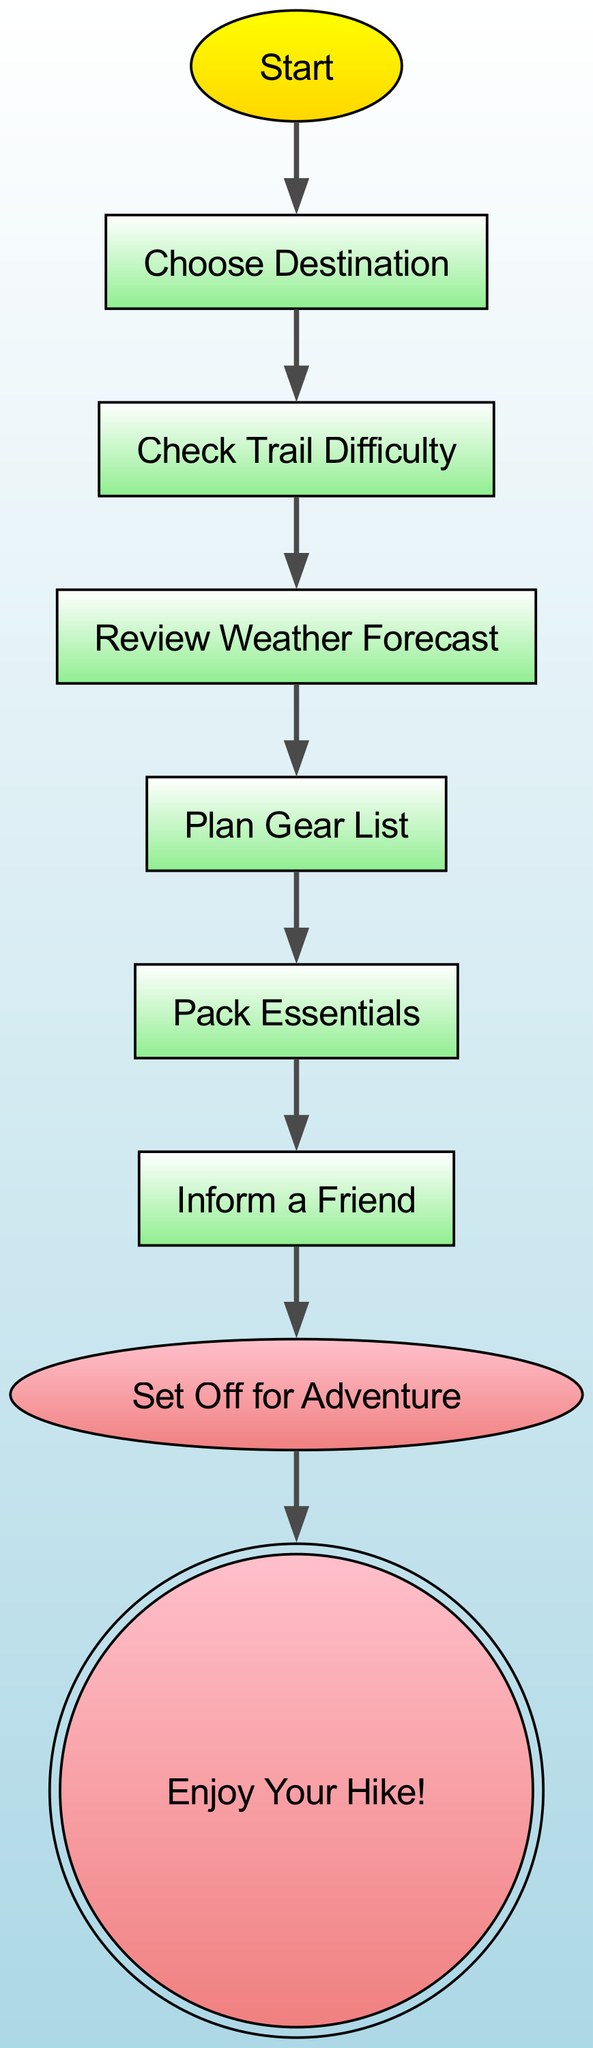What is the first step in the hiking preparation checklist? The flowchart indicates that the first node is "Start," which then leads to "Choose Destination." Therefore, the first step in the checklist is "Choose Destination."
Answer: Choose Destination How many steps are there before setting off for the adventure? Counting the nodes from "Choose Destination" to "Set Off for Adventure," there are six steps in total: "Choose Destination," "Check Trail Difficulty," "Review Weather Forecast," "Plan Gear List," "Pack Essentials," and "Inform a Friend."
Answer: 6 What is the last step in the hiking preparation checklist? The last node in the flowchart is "Enjoy Your Hike!" which follows "Set Off for Adventure." Therefore, the last step is "Enjoy Your Hike!"
Answer: Enjoy Your Hike! What step follows "Review Weather Forecast"? According to the flowchart, after the node "Review Weather Forecast," the next step is "Plan Gear List." This can be directly seen in the flow from the first to the subsequent steps.
Answer: Plan Gear List What color represents the "Start" node? In the diagram, the "Start" node is colored in gold to yellow gradient, making it distinct from other nodes.
Answer: Gold to yellow gradient What is the relationship between "Inform a Friend" and "Set Off for Adventure"? The diagram shows a direct connection where "Inform a Friend" leads to "Set Off for Adventure." This indicates that you need to inform a friend before you can set off on the hike.
Answer: Inform a Friend leads to Set Off for Adventure How many nodes are there in total in the hiking preparation checklist? The checklist includes the following nodes: "Start," "Choose Destination," "Check Trail Difficulty," "Review Weather Forecast," "Plan Gear List," "Pack Essentials," "Inform a Friend," "Set Off for Adventure," and "Enjoy Your Hike!" Counting all these gives a total of nine nodes.
Answer: 9 What step requires you to review the weather? The step that involves reviewing the weather is labeled as "Review Weather Forecast," derived from the direct sequence of steps in the flowchart.
Answer: Review Weather Forecast What color is the "End" node? The "End" node is colored in light coral to pink gradient, which is visually distinguishable from other nodes in the flowchart.
Answer: Light coral to pink gradient 